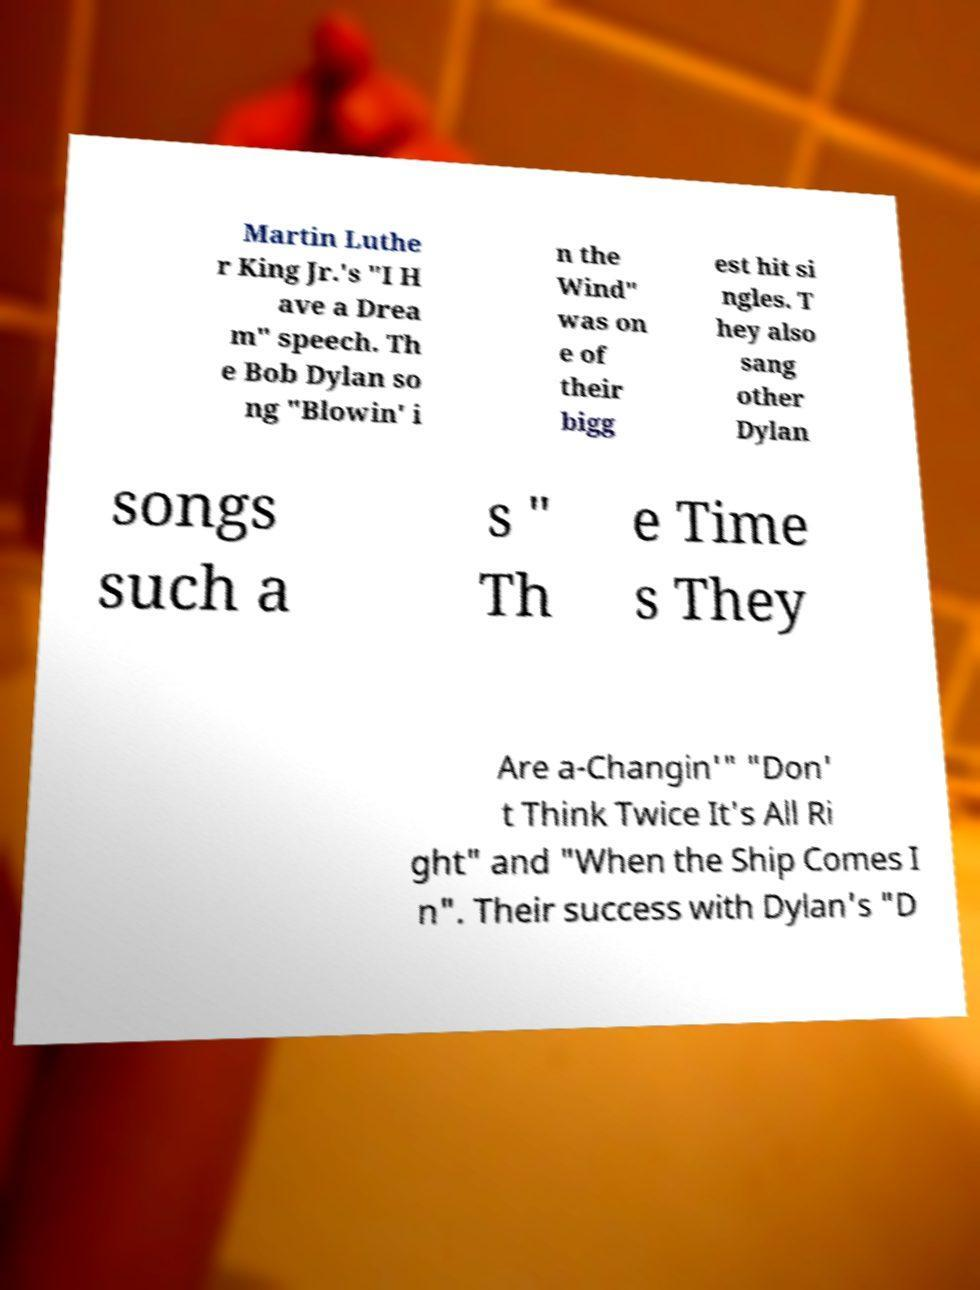Please identify and transcribe the text found in this image. Martin Luthe r King Jr.'s "I H ave a Drea m" speech. Th e Bob Dylan so ng "Blowin' i n the Wind" was on e of their bigg est hit si ngles. T hey also sang other Dylan songs such a s " Th e Time s They Are a-Changin'" "Don' t Think Twice It's All Ri ght" and "When the Ship Comes I n". Their success with Dylan's "D 